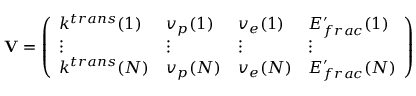Convert formula to latex. <formula><loc_0><loc_0><loc_500><loc_500>V = \left ( \begin{array} { l l l l } { k ^ { t r a n s } ( 1 ) } & { v _ { p } ( 1 ) } & { v _ { e } ( 1 ) } & { E _ { f r a c } ^ { \prime } ( 1 ) } \\ { \vdots } & { \vdots } & { \vdots } & { \vdots } \\ { k ^ { t r a n s } ( N ) } & { v _ { p } ( N ) } & { v _ { e } ( N ) } & { E _ { f r a c } ^ { \prime } ( N ) } \end{array} \right )</formula> 